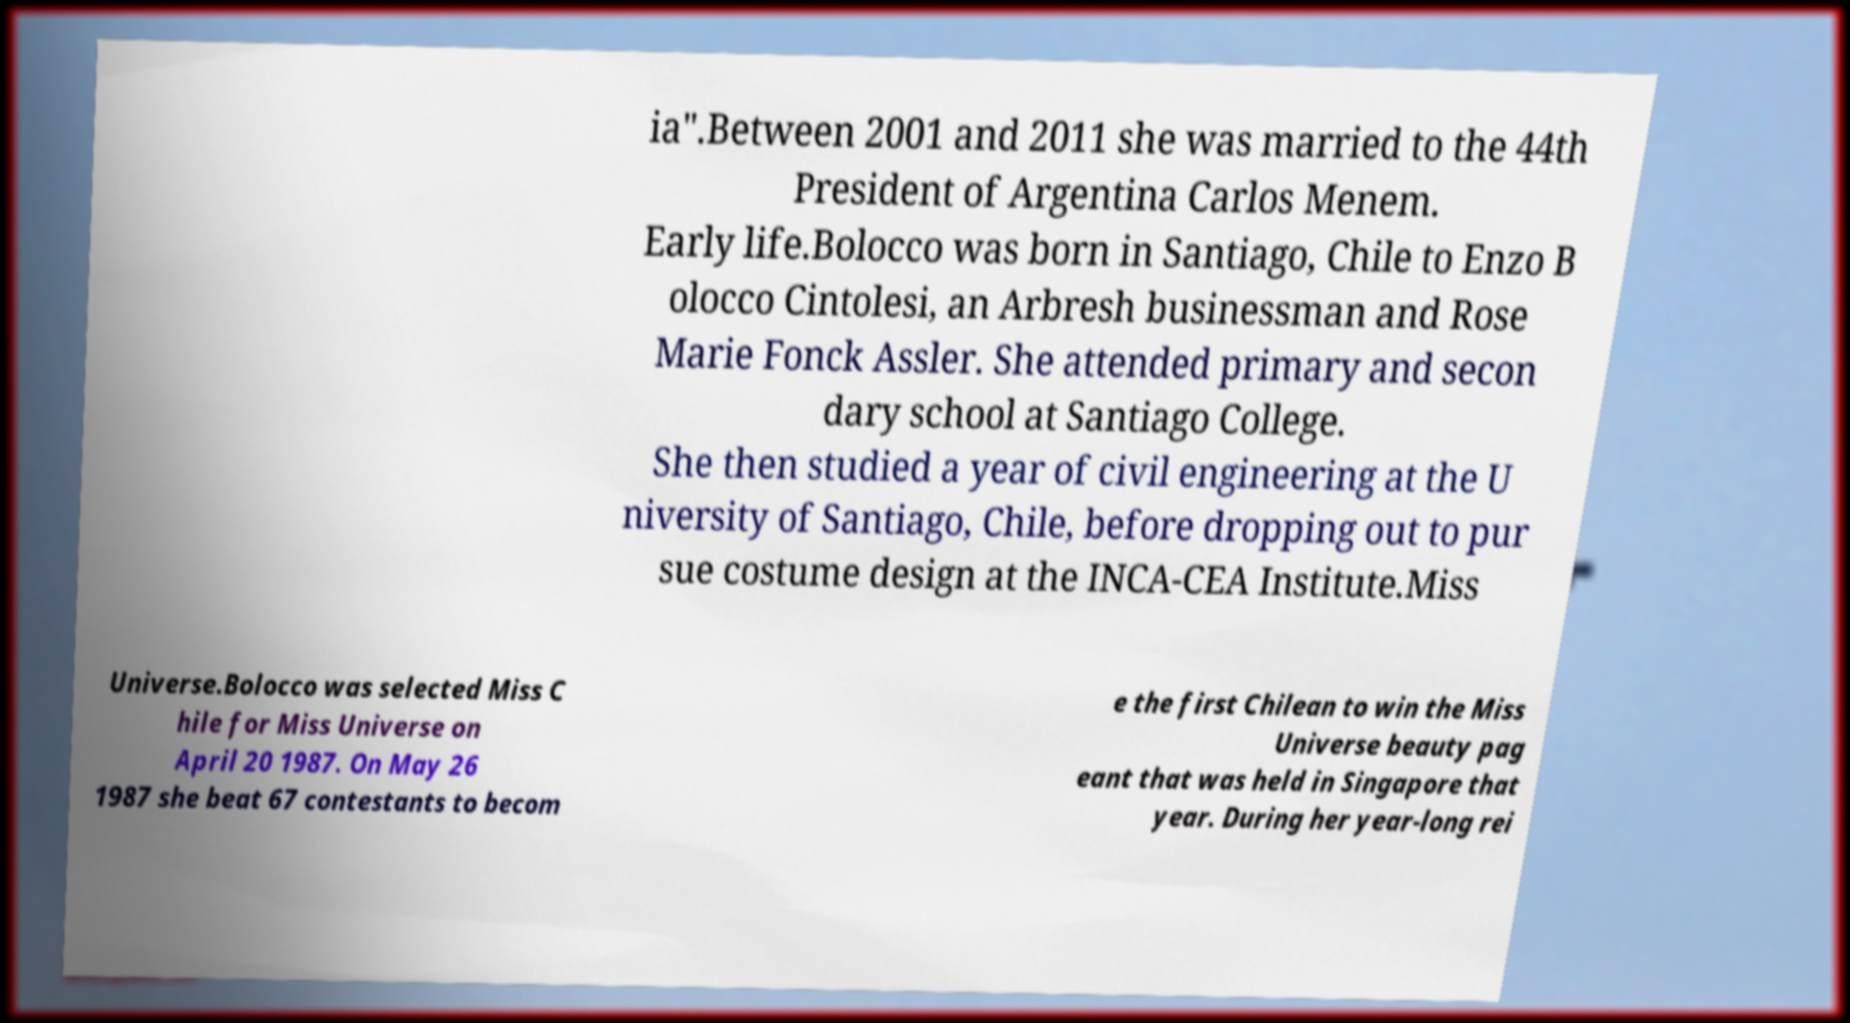What messages or text are displayed in this image? I need them in a readable, typed format. ia".Between 2001 and 2011 she was married to the 44th President of Argentina Carlos Menem. Early life.Bolocco was born in Santiago, Chile to Enzo B olocco Cintolesi, an Arbresh businessman and Rose Marie Fonck Assler. She attended primary and secon dary school at Santiago College. She then studied a year of civil engineering at the U niversity of Santiago, Chile, before dropping out to pur sue costume design at the INCA-CEA Institute.Miss Universe.Bolocco was selected Miss C hile for Miss Universe on April 20 1987. On May 26 1987 she beat 67 contestants to becom e the first Chilean to win the Miss Universe beauty pag eant that was held in Singapore that year. During her year-long rei 